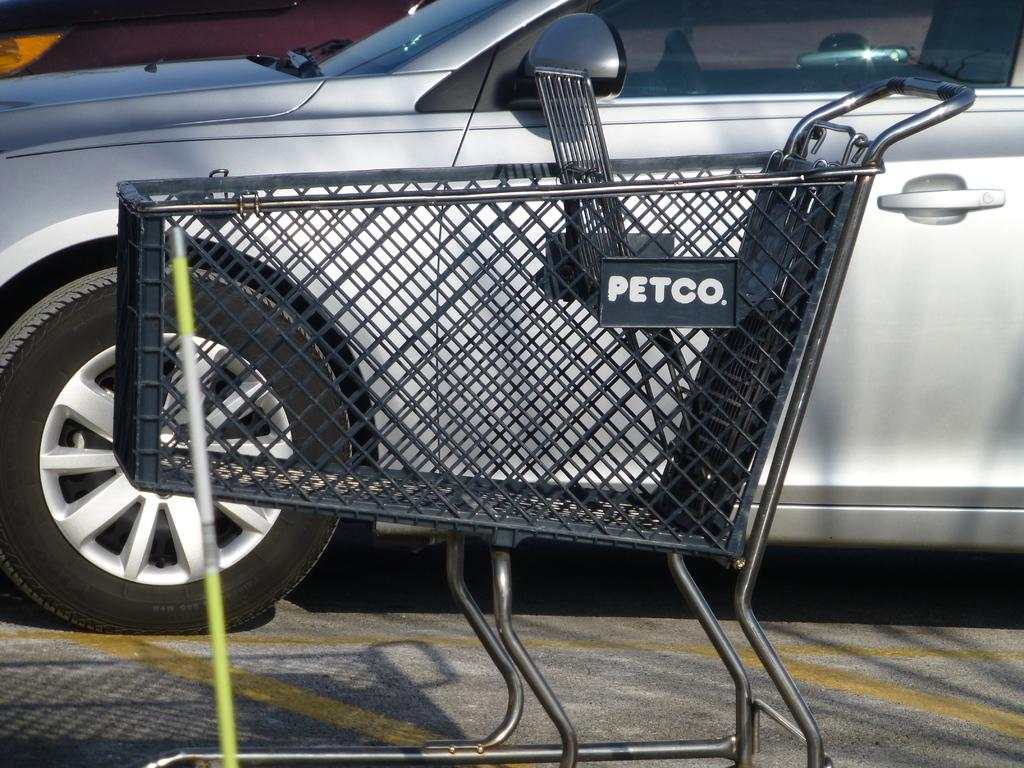What is the color of the trolley in the image? The trolley in the image is black. Can you describe the green and white object in the image? Unfortunately, the facts provided do not give a description of the green and white object. What type of vehicle is on the ground in the image? There is an ash-colored car on the ground in the image. How does the snail affect the acoustics in the image? There is no snail present in the image, so it cannot affect the acoustics. What type of adjustment is being made to the trolley in the image? The facts provided do not mention any adjustments being made to the trolley. 